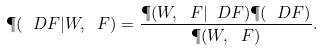<formula> <loc_0><loc_0><loc_500><loc_500>\P ( \ D F | W , \ F ) = \frac { \P ( W , \ F | \ D F ) \P ( \ D F ) } { \P ( W , \ F ) } .</formula> 